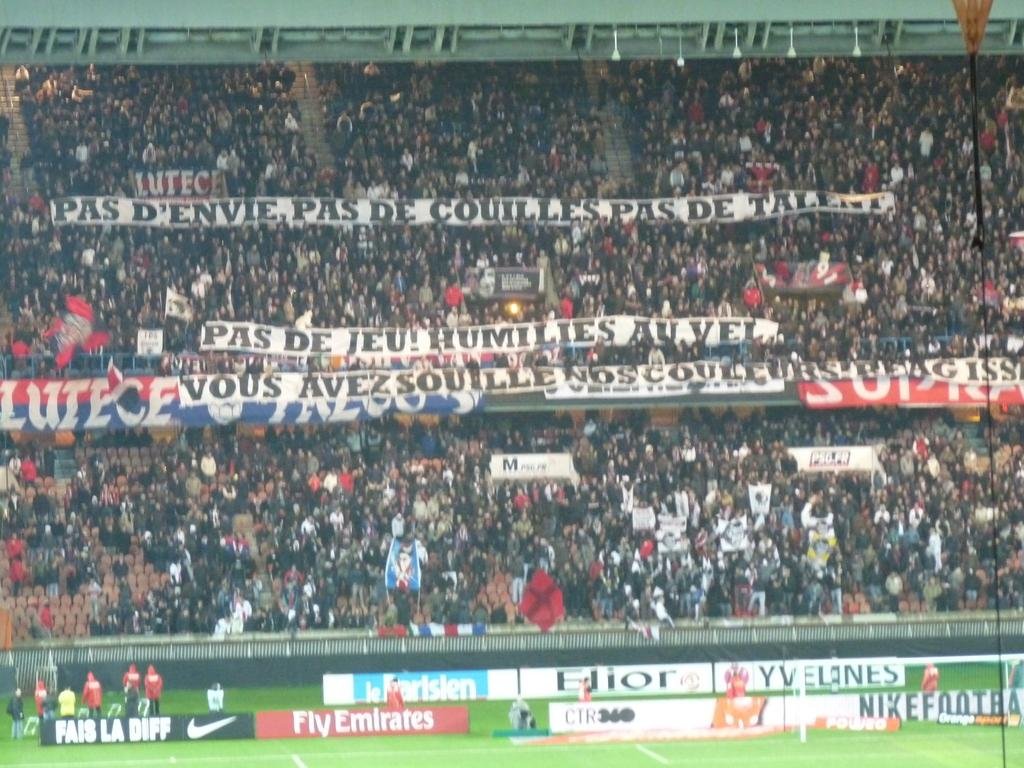Provide a one-sentence caption for the provided image. The crowd at a sporting event is holding up a big sign that reads Pas De Jeu Humilies Au Vel. 